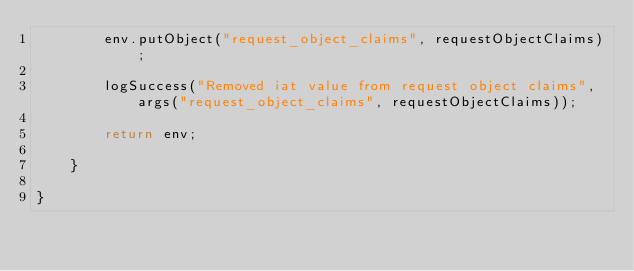<code> <loc_0><loc_0><loc_500><loc_500><_Java_>		env.putObject("request_object_claims", requestObjectClaims);

		logSuccess("Removed iat value from request object claims", args("request_object_claims", requestObjectClaims));

		return env;

	}

}
</code> 